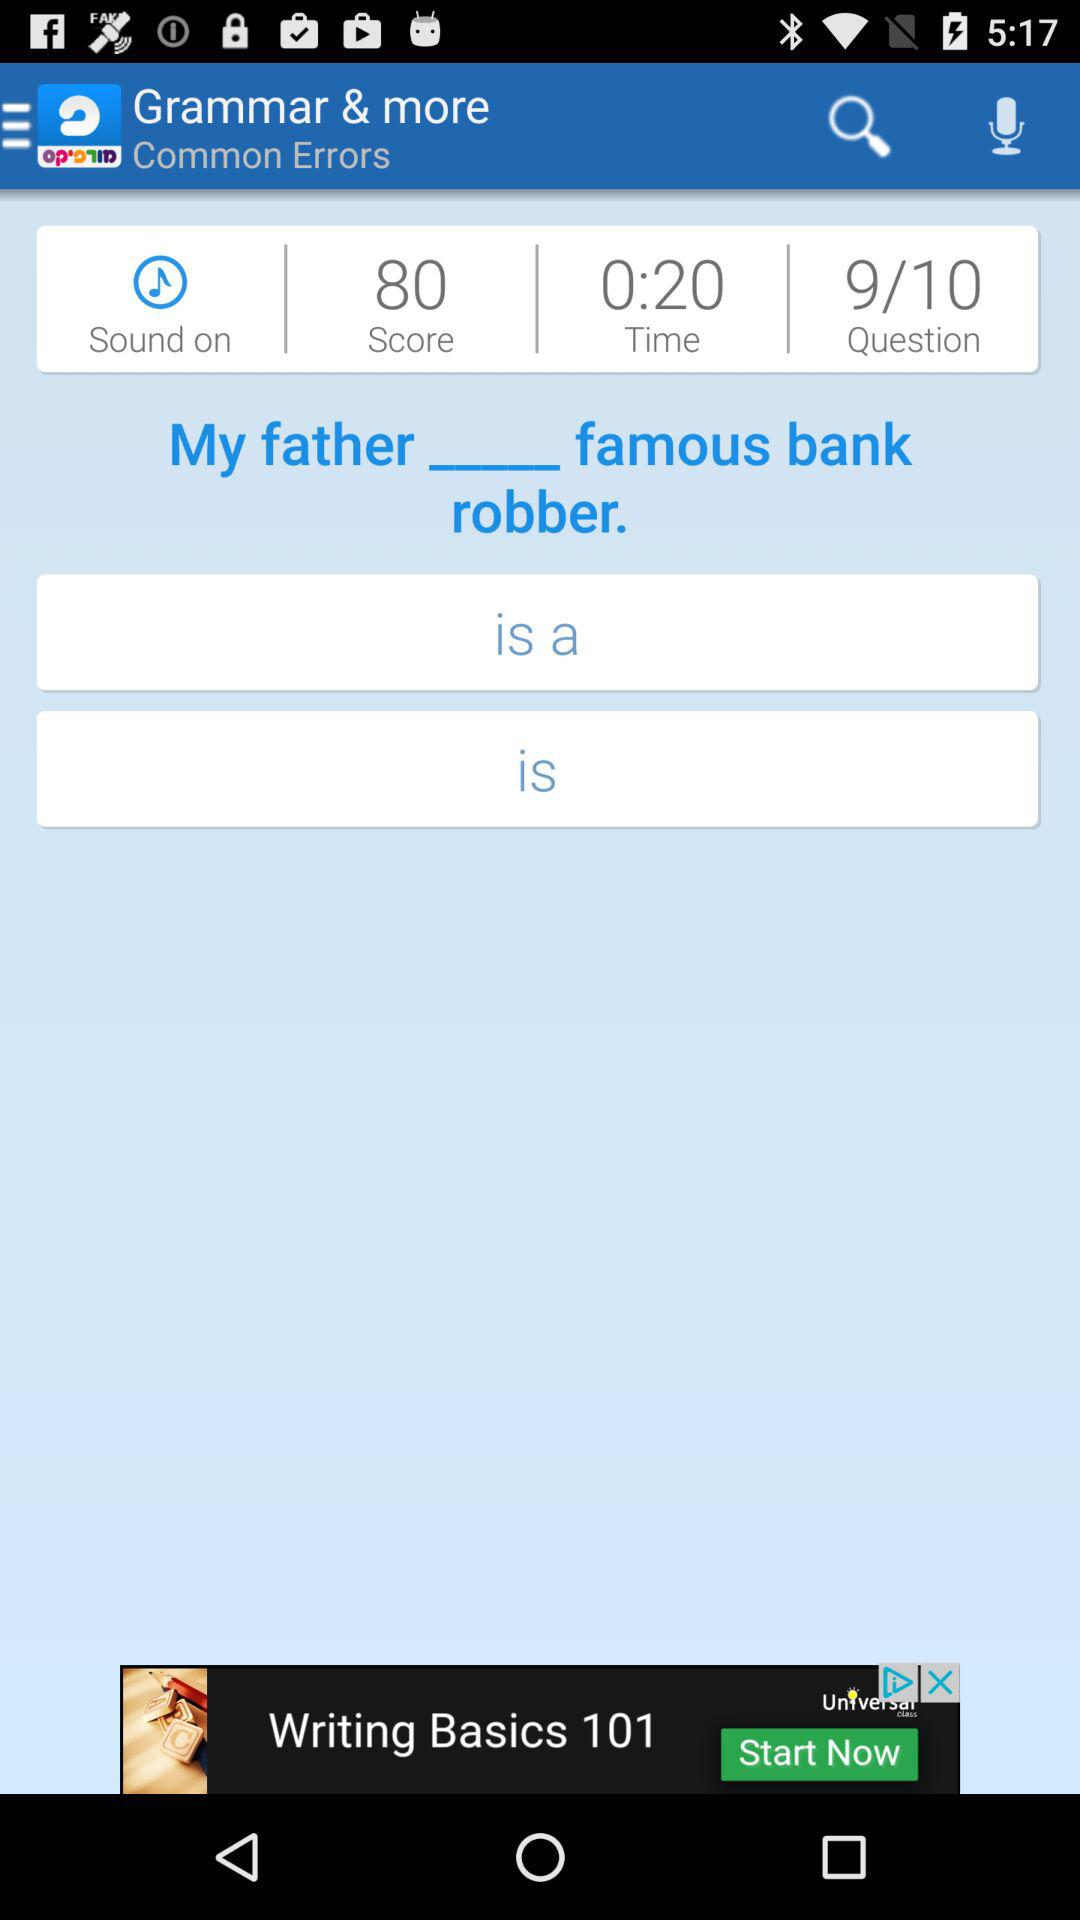What is the time duration for giving an answer? The time duration for giving an answer is 20 seconds. 